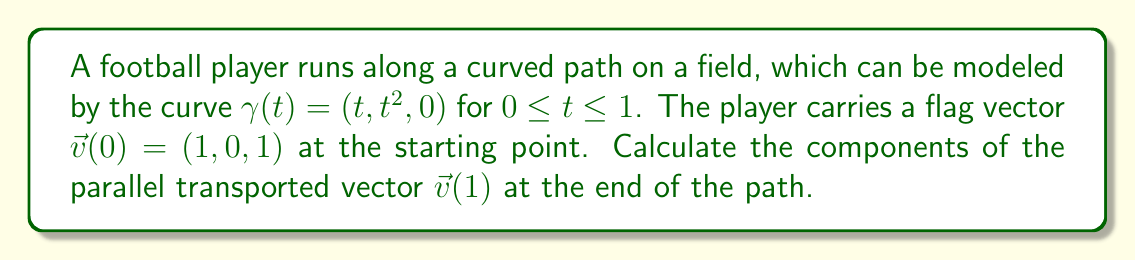What is the answer to this math problem? To solve this problem, we'll follow these steps:

1) First, we need to calculate the tangent vector $\vec{T}(t)$ to the curve:
   $$\vec{T}(t) = \frac{d\gamma}{dt} = (1, 2t, 0)$$

2) Normalize the tangent vector:
   $$\vec{T}(t) = \frac{(1, 2t, 0)}{\sqrt{1 + 4t^2}}$$

3) The parallel transport equation is:
   $$\frac{D\vec{v}}{dt} = 0$$
   Which means $\frac{d\vec{v}}{dt} = -(\frac{d\vec{v}}{dt} \cdot \vec{T})\vec{T}$

4) Let $\vec{v}(t) = (x(t), y(t), z(t))$. Then:
   $$\frac{d\vec{v}}{dt} = (x'(t), y'(t), z'(t))$$

5) Substituting into the parallel transport equation:
   $$(x'(t), y'(t), z'(t)) = -((x'(t), y'(t), z'(t)) \cdot \frac{(1, 2t, 0)}{\sqrt{1 + 4t^2}})\frac{(1, 2t, 0)}{\sqrt{1 + 4t^2}}$$

6) This gives us a system of differential equations:
   $$x'(t) = -\frac{x'(t) + 2ty'(t)}{1 + 4t^2}$$
   $$y'(t) = -\frac{2t(x'(t) + 2ty'(t))}{1 + 4t^2}$$
   $$z'(t) = 0$$

7) Solving this system with initial conditions $x(0) = 1$, $y(0) = 0$, $z(0) = 1$:
   $$x(t) = \frac{1}{\sqrt{1 + 4t^2}}$$
   $$y(t) = \frac{2t}{\sqrt{1 + 4t^2}}$$
   $$z(t) = 1$$

8) At $t = 1$, we have:
   $$\vec{v}(1) = (\frac{1}{\sqrt{5}}, \frac{2}{\sqrt{5}}, 1)$$
Answer: $(\frac{1}{\sqrt{5}}, \frac{2}{\sqrt{5}}, 1)$ 